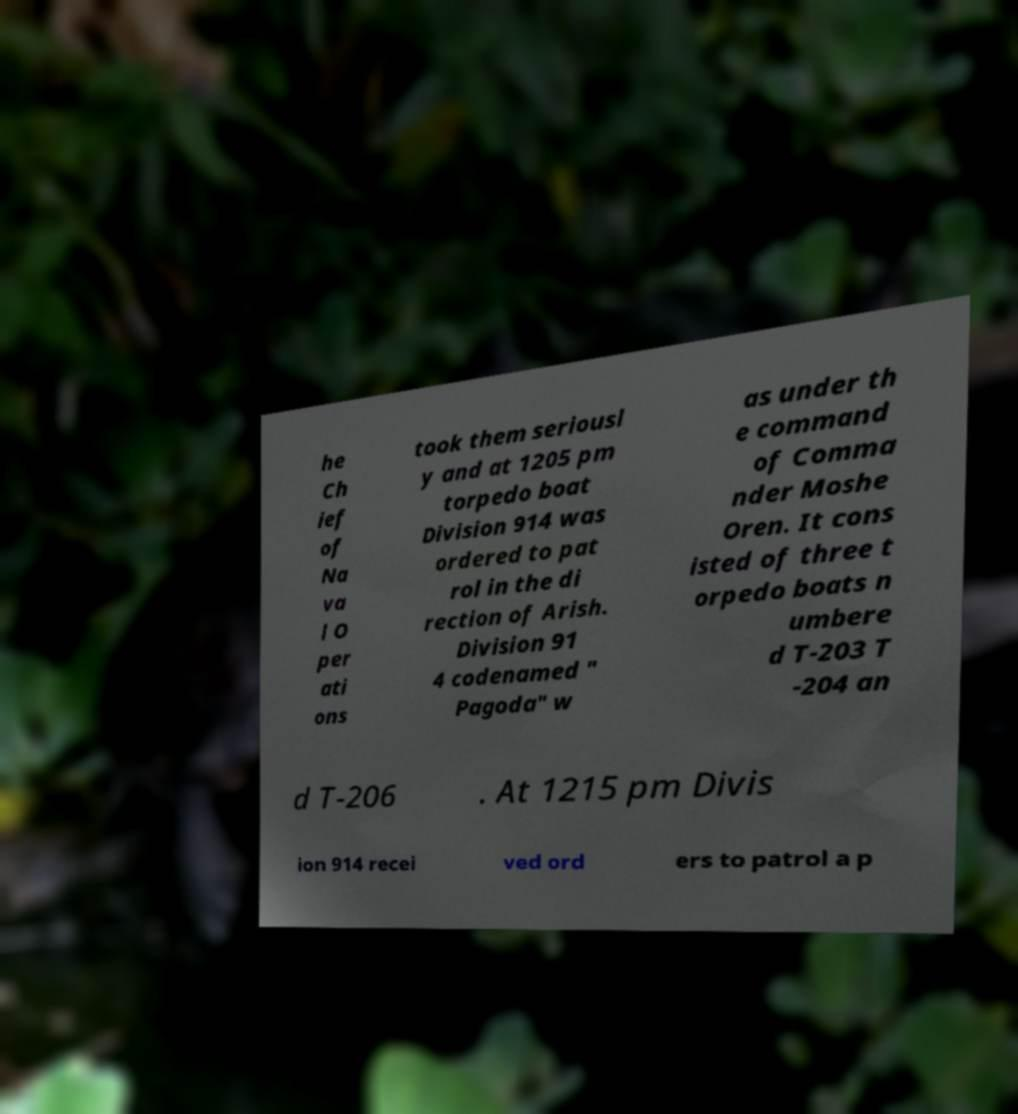What messages or text are displayed in this image? I need them in a readable, typed format. he Ch ief of Na va l O per ati ons took them seriousl y and at 1205 pm torpedo boat Division 914 was ordered to pat rol in the di rection of Arish. Division 91 4 codenamed " Pagoda" w as under th e command of Comma nder Moshe Oren. It cons isted of three t orpedo boats n umbere d T-203 T -204 an d T-206 . At 1215 pm Divis ion 914 recei ved ord ers to patrol a p 